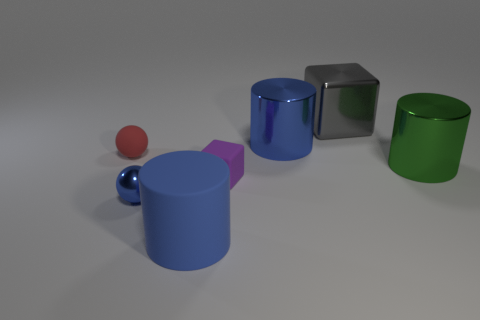Subtract all gray balls. How many blue cylinders are left? 2 Add 3 brown shiny blocks. How many objects exist? 10 Subtract all large blue matte cylinders. How many cylinders are left? 2 Subtract all blocks. How many objects are left? 5 Subtract all red cylinders. Subtract all yellow cubes. How many cylinders are left? 3 Subtract all balls. Subtract all large gray objects. How many objects are left? 4 Add 4 tiny purple matte blocks. How many tiny purple matte blocks are left? 5 Add 6 green metal things. How many green metal things exist? 7 Subtract 0 gray balls. How many objects are left? 7 